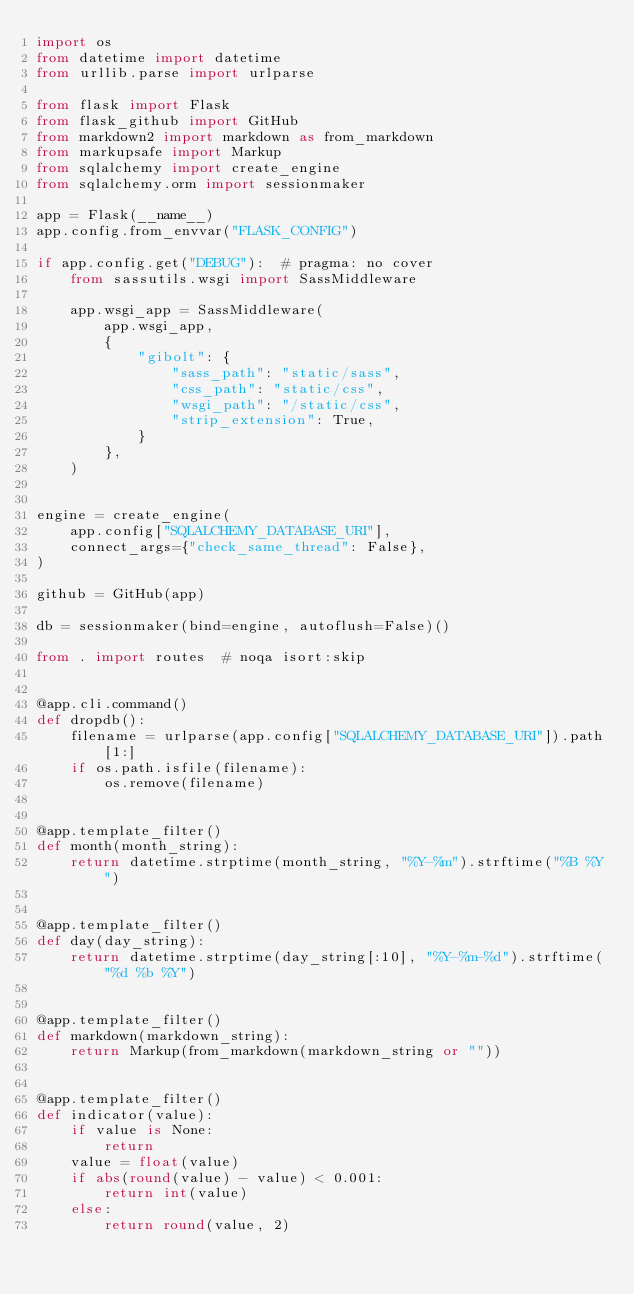Convert code to text. <code><loc_0><loc_0><loc_500><loc_500><_Python_>import os
from datetime import datetime
from urllib.parse import urlparse

from flask import Flask
from flask_github import GitHub
from markdown2 import markdown as from_markdown
from markupsafe import Markup
from sqlalchemy import create_engine
from sqlalchemy.orm import sessionmaker

app = Flask(__name__)
app.config.from_envvar("FLASK_CONFIG")

if app.config.get("DEBUG"):  # pragma: no cover
    from sassutils.wsgi import SassMiddleware

    app.wsgi_app = SassMiddleware(
        app.wsgi_app,
        {
            "gibolt": {
                "sass_path": "static/sass",
                "css_path": "static/css",
                "wsgi_path": "/static/css",
                "strip_extension": True,
            }
        },
    )


engine = create_engine(
    app.config["SQLALCHEMY_DATABASE_URI"],
    connect_args={"check_same_thread": False},
)

github = GitHub(app)

db = sessionmaker(bind=engine, autoflush=False)()

from . import routes  # noqa isort:skip


@app.cli.command()
def dropdb():
    filename = urlparse(app.config["SQLALCHEMY_DATABASE_URI"]).path[1:]
    if os.path.isfile(filename):
        os.remove(filename)


@app.template_filter()
def month(month_string):
    return datetime.strptime(month_string, "%Y-%m").strftime("%B %Y")


@app.template_filter()
def day(day_string):
    return datetime.strptime(day_string[:10], "%Y-%m-%d").strftime("%d %b %Y")


@app.template_filter()
def markdown(markdown_string):
    return Markup(from_markdown(markdown_string or ""))


@app.template_filter()
def indicator(value):
    if value is None:
        return
    value = float(value)
    if abs(round(value) - value) < 0.001:
        return int(value)
    else:
        return round(value, 2)
</code> 